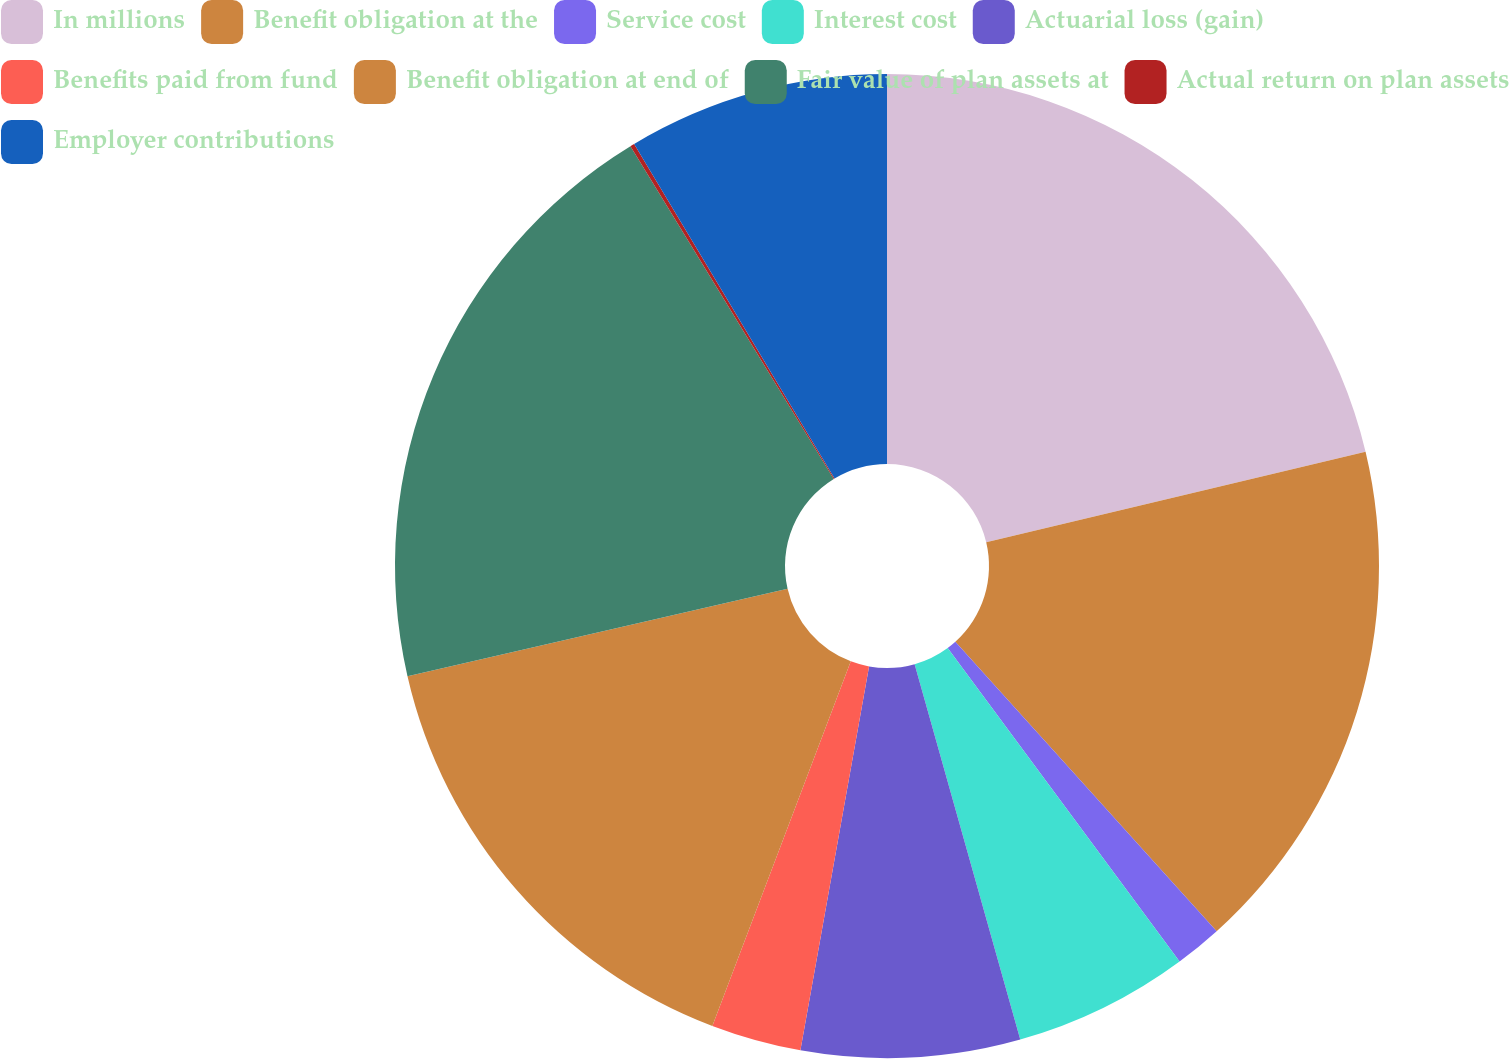Convert chart. <chart><loc_0><loc_0><loc_500><loc_500><pie_chart><fcel>In millions<fcel>Benefit obligation at the<fcel>Service cost<fcel>Interest cost<fcel>Actuarial loss (gain)<fcel>Benefits paid from fund<fcel>Benefit obligation at end of<fcel>Fair value of plan assets at<fcel>Actual return on plan assets<fcel>Employer contributions<nl><fcel>21.27%<fcel>17.04%<fcel>1.55%<fcel>5.77%<fcel>7.18%<fcel>2.96%<fcel>15.63%<fcel>19.86%<fcel>0.14%<fcel>8.59%<nl></chart> 